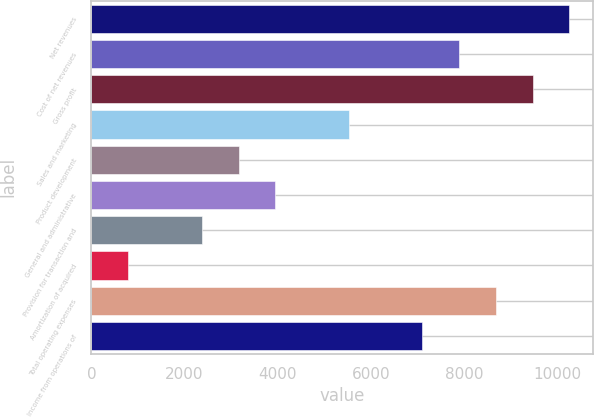Convert chart to OTSL. <chart><loc_0><loc_0><loc_500><loc_500><bar_chart><fcel>Net revenues<fcel>Cost of net revenues<fcel>Gross profit<fcel>Sales and marketing<fcel>Product development<fcel>General and administrative<fcel>Provision for transaction and<fcel>Amortization of acquired<fcel>Total operating expenses<fcel>Income from operations of<nl><fcel>10261.4<fcel>7895<fcel>9472.6<fcel>5528.6<fcel>3162.2<fcel>3951<fcel>2373.4<fcel>795.8<fcel>8683.8<fcel>7106.2<nl></chart> 